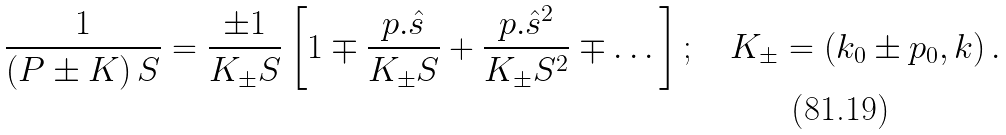Convert formula to latex. <formula><loc_0><loc_0><loc_500><loc_500>\frac { 1 } { \left ( P \pm K \right ) S } = \frac { \pm 1 } { K _ { \pm } S } \left [ 1 \mp \frac { p . \hat { s } } { K _ { \pm } S } + \frac { p . \hat { s } ^ { 2 } } { K _ { \pm } S ^ { 2 } } \mp \dots \right ] ; \quad K _ { \pm } = \left ( k _ { 0 } \pm p _ { 0 } , k \right ) .</formula> 